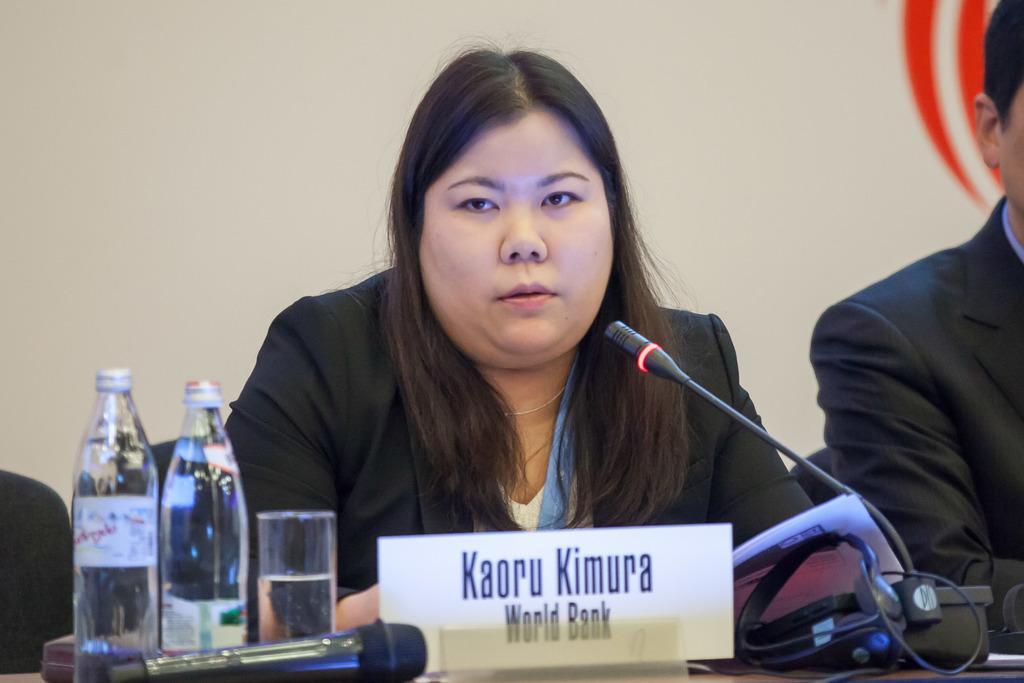How would you summarize this image in a sentence or two? In this picture there are two people sitting on chairs and we can see bottles, glass, microphones, headset, papers and board on the table. In the background of the image we can see wall. 